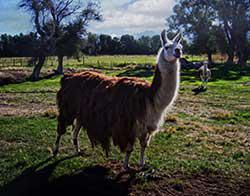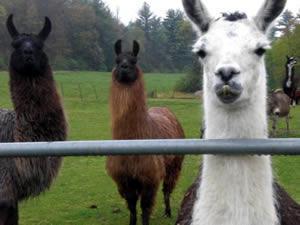The first image is the image on the left, the second image is the image on the right. Considering the images on both sides, is "There is at least one human in the pair of images." valid? Answer yes or no. No. The first image is the image on the left, the second image is the image on the right. Assess this claim about the two images: "A white rope is extending from the red harness on a right-facing llama with a mottled brown coat in one image.". Correct or not? Answer yes or no. No. 